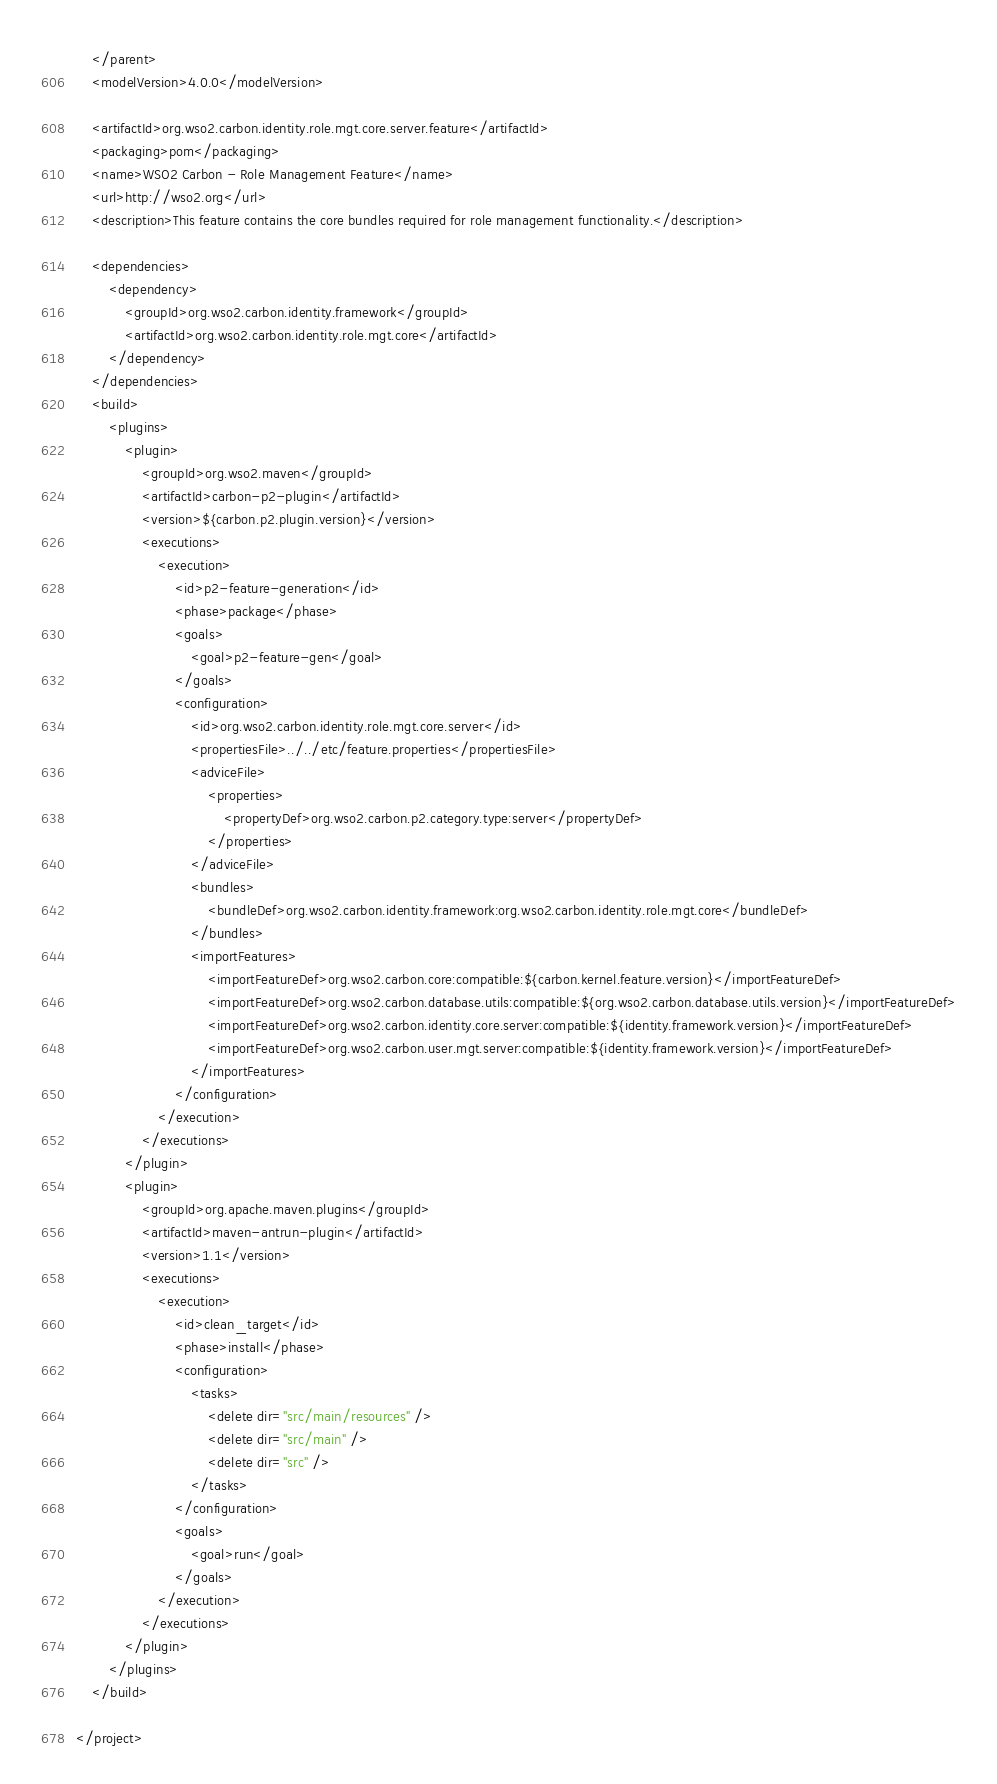<code> <loc_0><loc_0><loc_500><loc_500><_XML_>    </parent>
    <modelVersion>4.0.0</modelVersion>

    <artifactId>org.wso2.carbon.identity.role.mgt.core.server.feature</artifactId>
    <packaging>pom</packaging>
    <name>WSO2 Carbon - Role Management Feature</name>
    <url>http://wso2.org</url>
    <description>This feature contains the core bundles required for role management functionality.</description>

    <dependencies>
        <dependency>
            <groupId>org.wso2.carbon.identity.framework</groupId>
            <artifactId>org.wso2.carbon.identity.role.mgt.core</artifactId>
        </dependency>
    </dependencies>
    <build>
        <plugins>
            <plugin>
                <groupId>org.wso2.maven</groupId>
                <artifactId>carbon-p2-plugin</artifactId>
                <version>${carbon.p2.plugin.version}</version>
                <executions>
                    <execution>
                        <id>p2-feature-generation</id>
                        <phase>package</phase>
                        <goals>
                            <goal>p2-feature-gen</goal>
                        </goals>
                        <configuration>
                            <id>org.wso2.carbon.identity.role.mgt.core.server</id>
                            <propertiesFile>../../etc/feature.properties</propertiesFile>
                            <adviceFile>
                                <properties>
                                    <propertyDef>org.wso2.carbon.p2.category.type:server</propertyDef>
                                </properties>
                            </adviceFile>
                            <bundles>
                                <bundleDef>org.wso2.carbon.identity.framework:org.wso2.carbon.identity.role.mgt.core</bundleDef>
                            </bundles>
                            <importFeatures>
                                <importFeatureDef>org.wso2.carbon.core:compatible:${carbon.kernel.feature.version}</importFeatureDef>
                                <importFeatureDef>org.wso2.carbon.database.utils:compatible:${org.wso2.carbon.database.utils.version}</importFeatureDef>
                                <importFeatureDef>org.wso2.carbon.identity.core.server:compatible:${identity.framework.version}</importFeatureDef>
                                <importFeatureDef>org.wso2.carbon.user.mgt.server:compatible:${identity.framework.version}</importFeatureDef>
                            </importFeatures>
                        </configuration>
                    </execution>
                </executions>
            </plugin>
            <plugin>
                <groupId>org.apache.maven.plugins</groupId>
                <artifactId>maven-antrun-plugin</artifactId>
                <version>1.1</version>
                <executions>
                    <execution>
                        <id>clean_target</id>
                        <phase>install</phase>
                        <configuration>
                            <tasks>
                                <delete dir="src/main/resources" />
                                <delete dir="src/main" />
                                <delete dir="src" />
                            </tasks>
                        </configuration>
                        <goals>
                            <goal>run</goal>
                        </goals>
                    </execution>
                </executions>
            </plugin>
        </plugins>
    </build>

</project>
</code> 